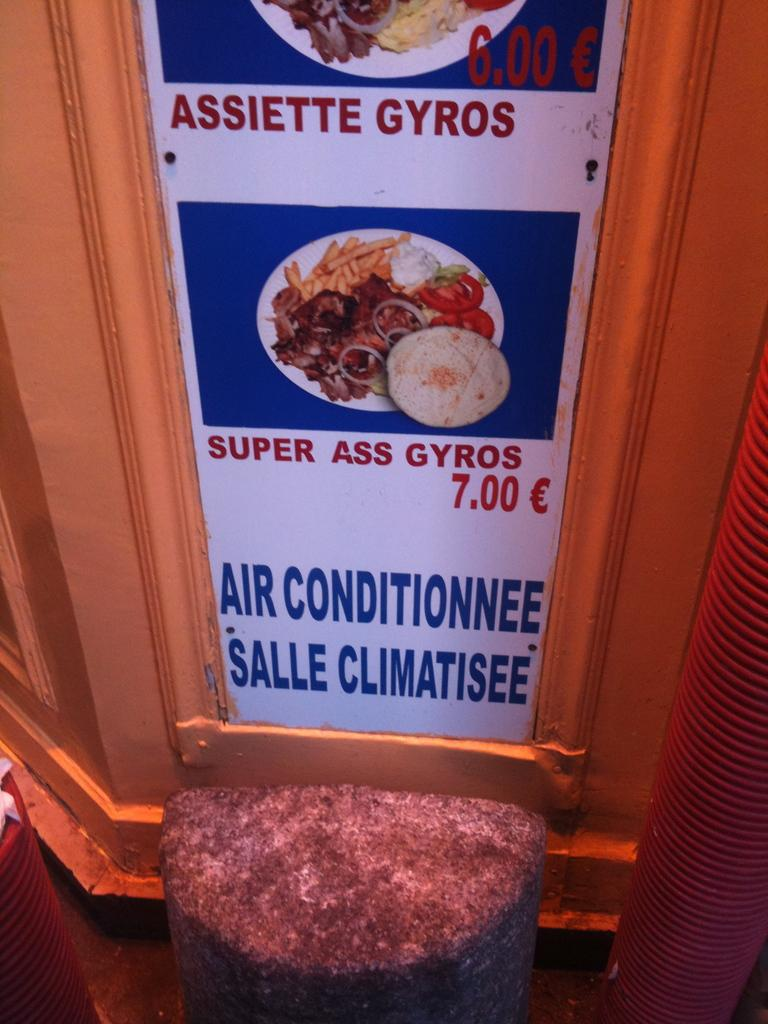Where is the menu board located in the image? The menu board is attached to the wall. What can be seen on the menu board? There are pictures of food on the menu board. What type of seating is available in the image? There is a stool present. How many men are visible in the image? There are no men present in the image. Is there a light bulb hanging from the ceiling in the image? There is no light bulb visible in the image. 